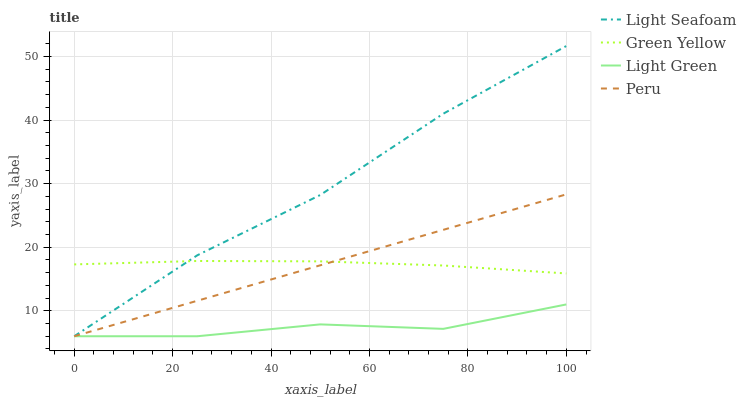Does Light Green have the minimum area under the curve?
Answer yes or no. Yes. Does Light Seafoam have the maximum area under the curve?
Answer yes or no. Yes. Does Peru have the minimum area under the curve?
Answer yes or no. No. Does Peru have the maximum area under the curve?
Answer yes or no. No. Is Peru the smoothest?
Answer yes or no. Yes. Is Light Green the roughest?
Answer yes or no. Yes. Is Light Seafoam the smoothest?
Answer yes or no. No. Is Light Seafoam the roughest?
Answer yes or no. No. Does Light Seafoam have the lowest value?
Answer yes or no. Yes. Does Light Seafoam have the highest value?
Answer yes or no. Yes. Does Peru have the highest value?
Answer yes or no. No. Is Light Green less than Green Yellow?
Answer yes or no. Yes. Is Green Yellow greater than Light Green?
Answer yes or no. Yes. Does Light Seafoam intersect Green Yellow?
Answer yes or no. Yes. Is Light Seafoam less than Green Yellow?
Answer yes or no. No. Is Light Seafoam greater than Green Yellow?
Answer yes or no. No. Does Light Green intersect Green Yellow?
Answer yes or no. No. 